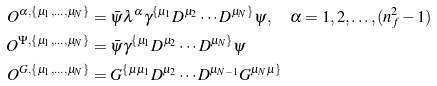<formula> <loc_0><loc_0><loc_500><loc_500>O ^ { \alpha , \{ \mu _ { 1 } , \dots , \mu _ { N } \} } & = \bar { \psi } \lambda ^ { \alpha } \gamma ^ { \{ \mu _ { 1 } } D ^ { \mu _ { 2 } } \cdots D ^ { \mu _ { N } \} } \psi , \quad \alpha = 1 , 2 , \dots , ( n _ { f } ^ { 2 } - 1 ) \\ O ^ { \Psi , \{ \mu _ { 1 } , \dots , \mu _ { N } \} } & = \bar { \psi } \gamma ^ { \{ \mu _ { 1 } } D ^ { \mu _ { 2 } } \cdots D ^ { \mu _ { N } \} } \psi \\ O ^ { G , \{ \mu _ { 1 } , \dots , \mu _ { N } \} } & = G ^ { \{ \mu \mu _ { 1 } } D ^ { \mu _ { 2 } } \cdots D ^ { \mu _ { N - 1 } } G ^ { \mu _ { N } \mu \} }</formula> 